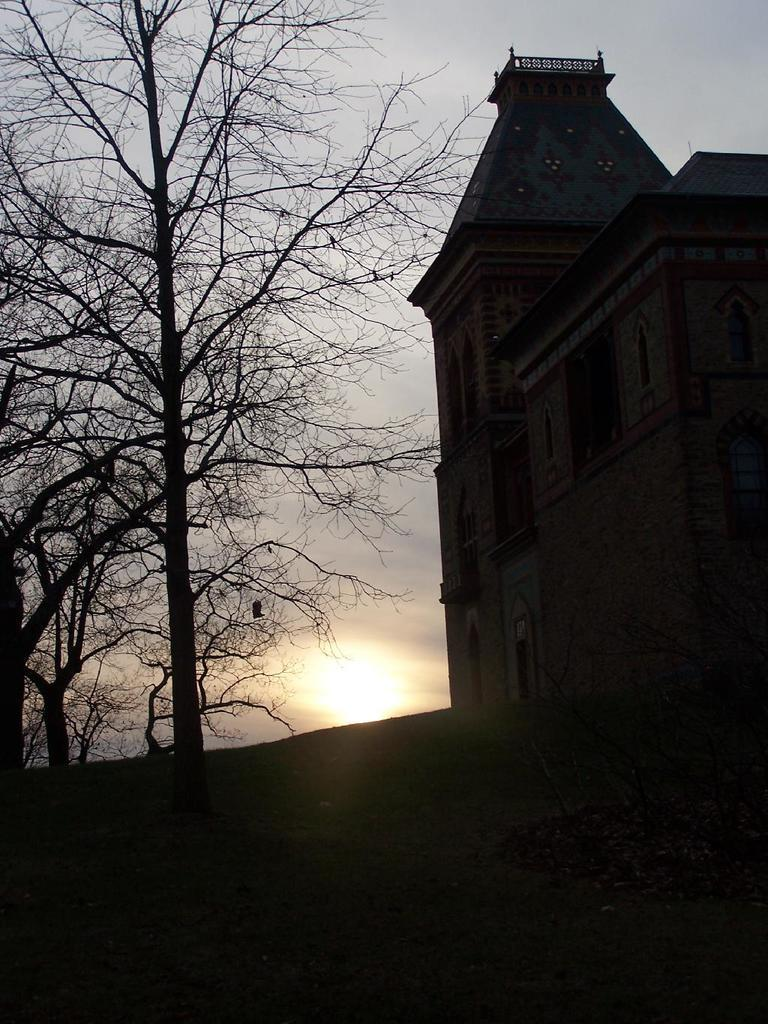What type of structure is present in the image? There is a building in the image. What can be seen beneath the building? The ground is visible in the image. What type of vegetation is present in the image? There are trees in the image. What is visible in the background of the image? The sky is visible in the background of the image. Can the sun be seen in the image? Yes, the sun is observable in the background of the image. What type of sugar is being used to grow the cabbage in the image? There is no cabbage or sugar present in the image; it features a building, ground, trees, sky, and the sun. 